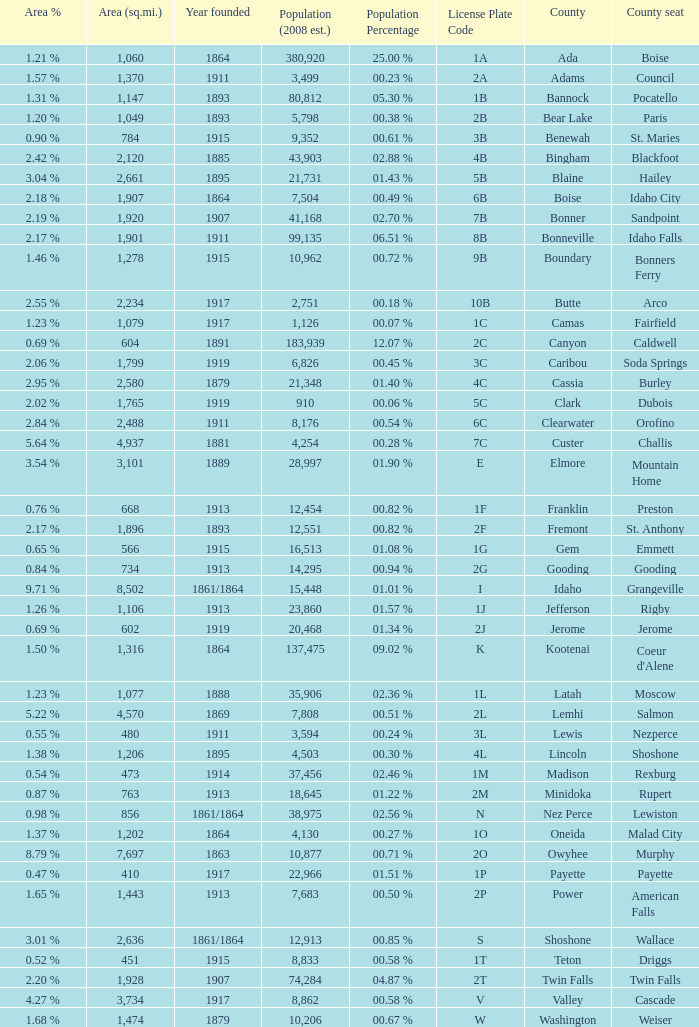What is the license plate code for the country with an area of 784? 3B. 